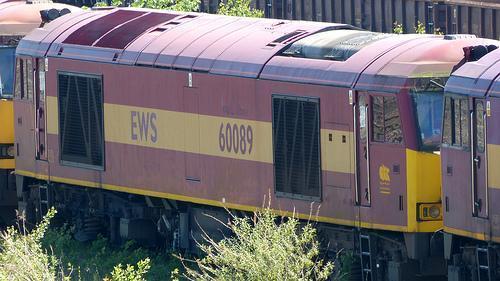How many cars are there?
Give a very brief answer. 3. 